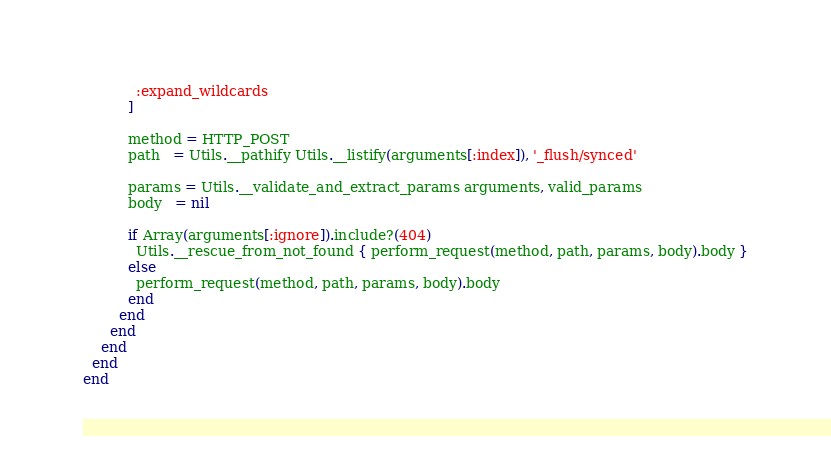Convert code to text. <code><loc_0><loc_0><loc_500><loc_500><_Ruby_>            :expand_wildcards
          ]

          method = HTTP_POST
          path   = Utils.__pathify Utils.__listify(arguments[:index]), '_flush/synced'

          params = Utils.__validate_and_extract_params arguments, valid_params
          body   = nil

          if Array(arguments[:ignore]).include?(404)
            Utils.__rescue_from_not_found { perform_request(method, path, params, body).body }
          else
            perform_request(method, path, params, body).body
          end
        end
      end
    end
  end
end
</code> 